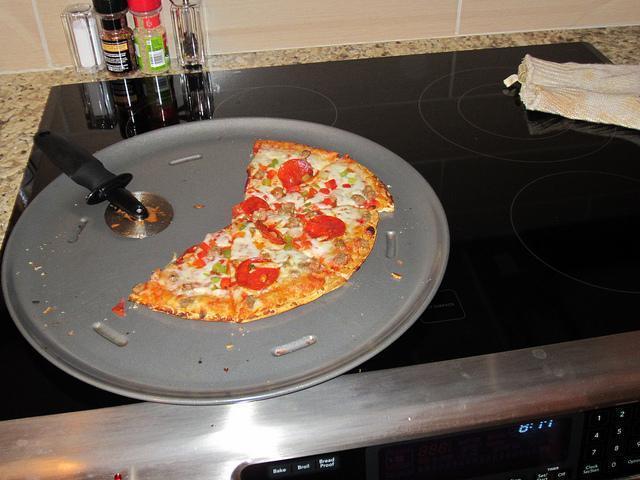How many slices are left?
Give a very brief answer. 5. How many slices of pizza are on the pan?
Give a very brief answer. 5. How many burners are on the stove?
Give a very brief answer. 4. How many bottles are there?
Give a very brief answer. 3. How many smiling people are there?
Give a very brief answer. 0. 